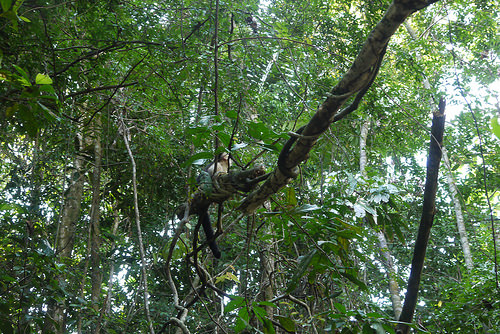<image>
Is there a sky under the tree? No. The sky is not positioned under the tree. The vertical relationship between these objects is different. 